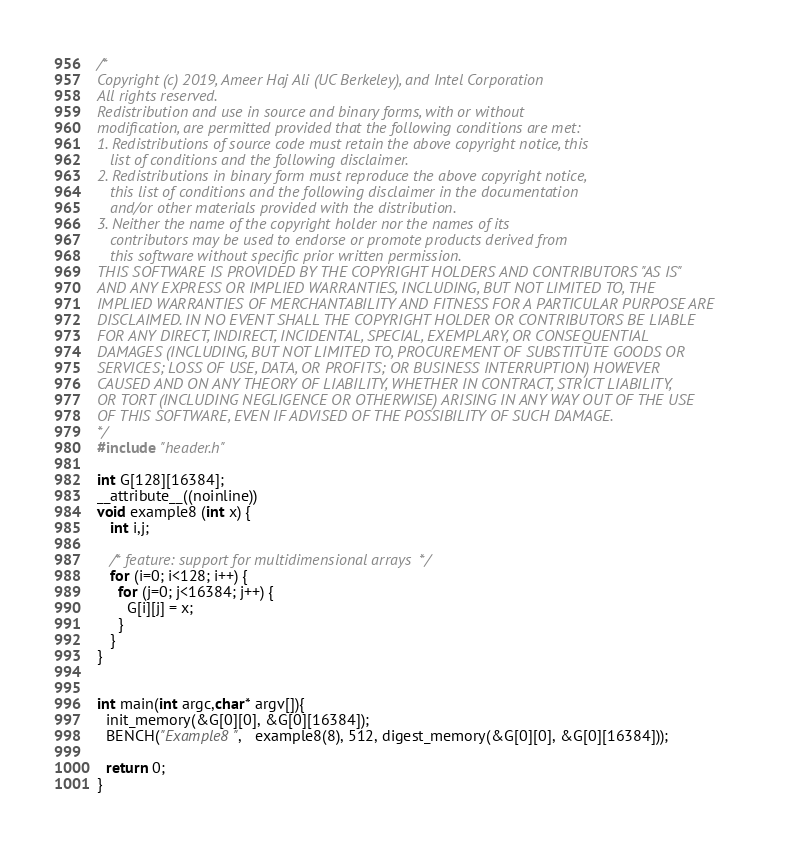<code> <loc_0><loc_0><loc_500><loc_500><_C_>/*
Copyright (c) 2019, Ameer Haj Ali (UC Berkeley), and Intel Corporation
All rights reserved.
Redistribution and use in source and binary forms, with or without
modification, are permitted provided that the following conditions are met:
1. Redistributions of source code must retain the above copyright notice, this
   list of conditions and the following disclaimer.
2. Redistributions in binary form must reproduce the above copyright notice,
   this list of conditions and the following disclaimer in the documentation
   and/or other materials provided with the distribution.
3. Neither the name of the copyright holder nor the names of its
   contributors may be used to endorse or promote products derived from
   this software without specific prior written permission.
THIS SOFTWARE IS PROVIDED BY THE COPYRIGHT HOLDERS AND CONTRIBUTORS "AS IS"
AND ANY EXPRESS OR IMPLIED WARRANTIES, INCLUDING, BUT NOT LIMITED TO, THE
IMPLIED WARRANTIES OF MERCHANTABILITY AND FITNESS FOR A PARTICULAR PURPOSE ARE
DISCLAIMED. IN NO EVENT SHALL THE COPYRIGHT HOLDER OR CONTRIBUTORS BE LIABLE
FOR ANY DIRECT, INDIRECT, INCIDENTAL, SPECIAL, EXEMPLARY, OR CONSEQUENTIAL
DAMAGES (INCLUDING, BUT NOT LIMITED TO, PROCUREMENT OF SUBSTITUTE GOODS OR
SERVICES; LOSS OF USE, DATA, OR PROFITS; OR BUSINESS INTERRUPTION) HOWEVER
CAUSED AND ON ANY THEORY OF LIABILITY, WHETHER IN CONTRACT, STRICT LIABILITY,
OR TORT (INCLUDING NEGLIGENCE OR OTHERWISE) ARISING IN ANY WAY OUT OF THE USE
OF THIS SOFTWARE, EVEN IF ADVISED OF THE POSSIBILITY OF SUCH DAMAGE.
*/
#include "header.h"

int G[128][16384];
__attribute__((noinline))
void example8 (int x) {
   int i,j;

   /* feature: support for multidimensional arrays  */
   for (i=0; i<128; i++) {
     for (j=0; j<16384; j++) {
       G[i][j] = x;
     }
   }
}


int main(int argc,char* argv[]){
  init_memory(&G[0][0], &G[0][16384]);
  BENCH("Example8",   example8(8), 512, digest_memory(&G[0][0], &G[0][16384]));
 
  return 0;
}
</code> 